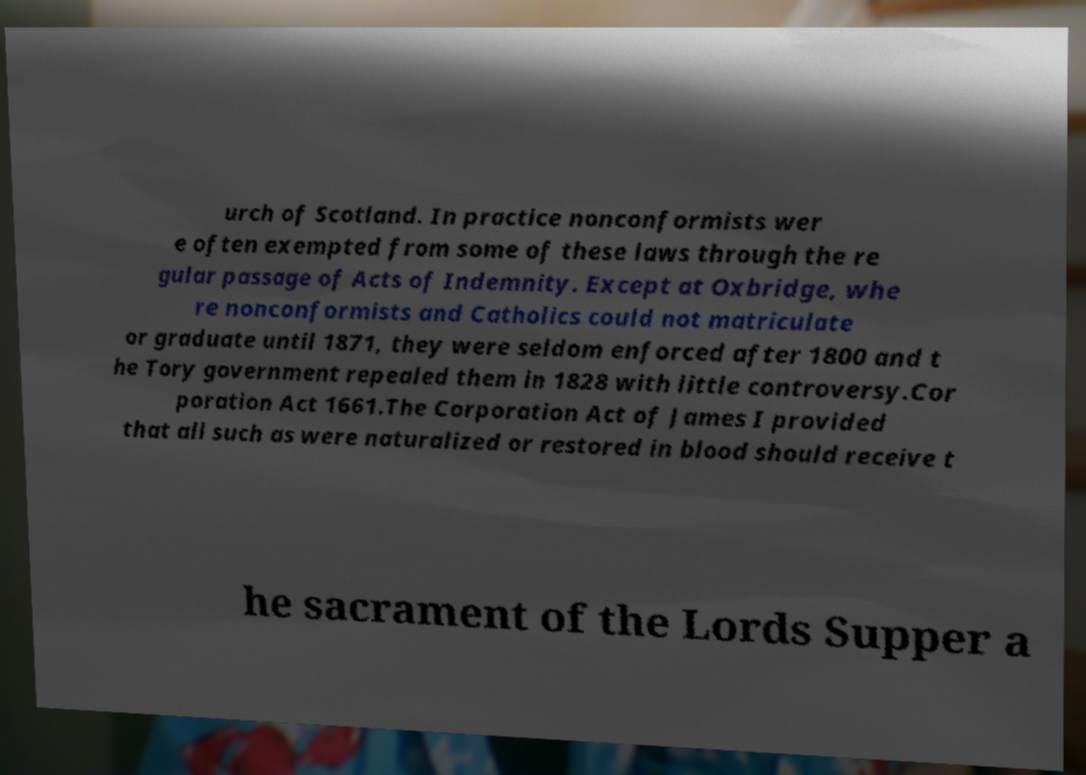Can you read and provide the text displayed in the image?This photo seems to have some interesting text. Can you extract and type it out for me? urch of Scotland. In practice nonconformists wer e often exempted from some of these laws through the re gular passage of Acts of Indemnity. Except at Oxbridge, whe re nonconformists and Catholics could not matriculate or graduate until 1871, they were seldom enforced after 1800 and t he Tory government repealed them in 1828 with little controversy.Cor poration Act 1661.The Corporation Act of James I provided that all such as were naturalized or restored in blood should receive t he sacrament of the Lords Supper a 